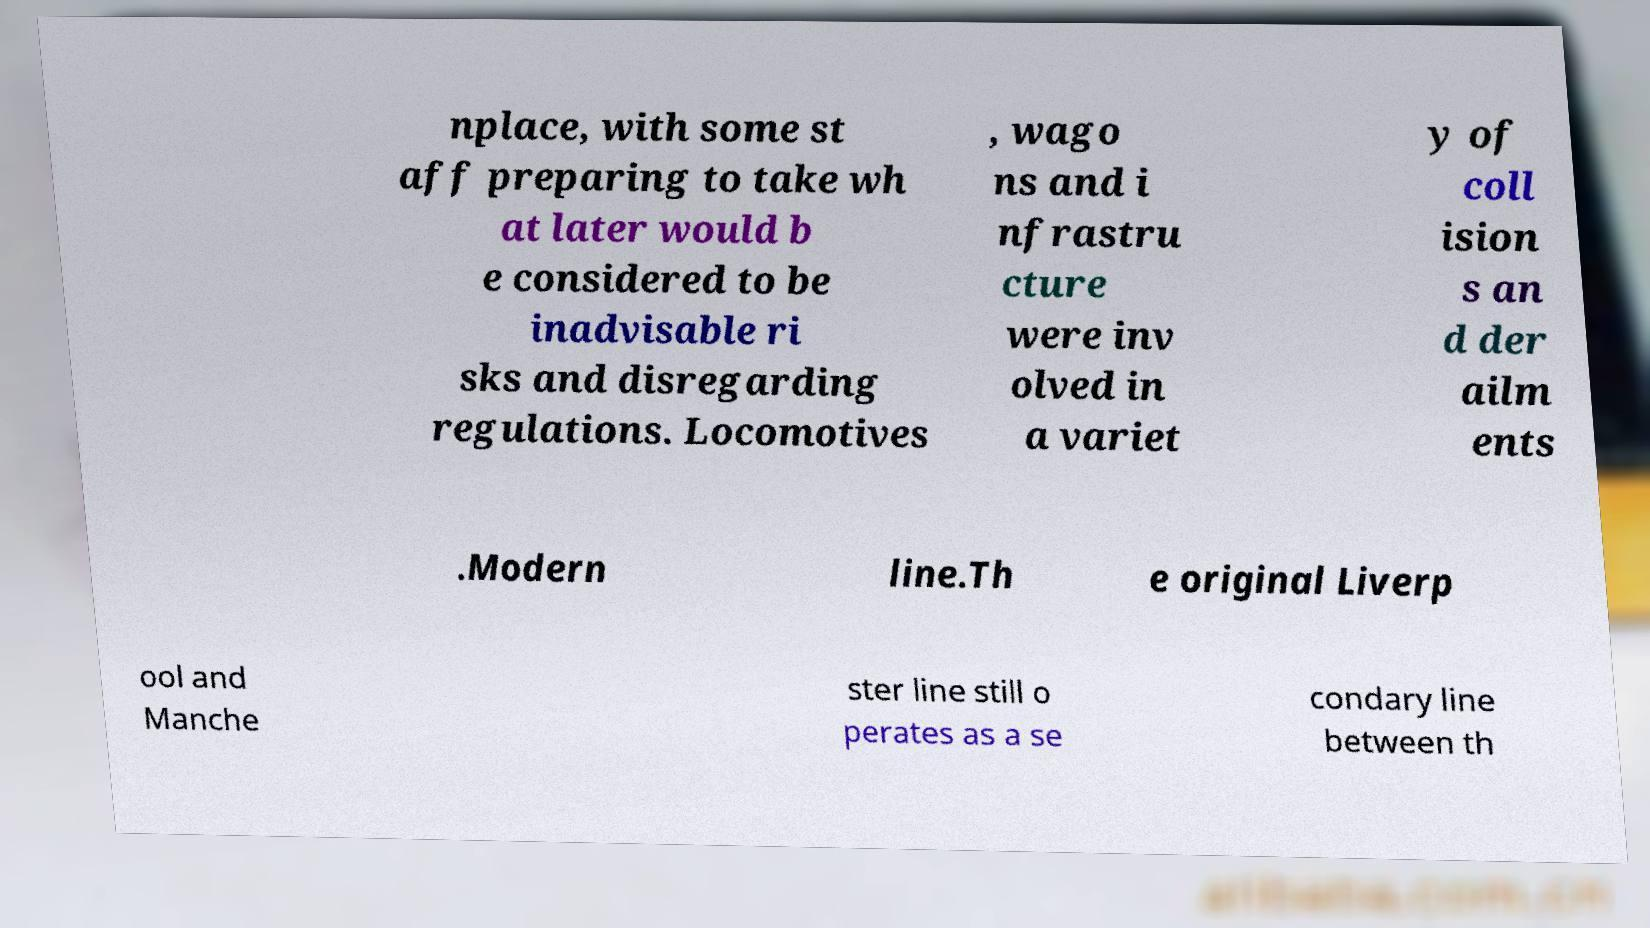Can you accurately transcribe the text from the provided image for me? nplace, with some st aff preparing to take wh at later would b e considered to be inadvisable ri sks and disregarding regulations. Locomotives , wago ns and i nfrastru cture were inv olved in a variet y of coll ision s an d der ailm ents .Modern line.Th e original Liverp ool and Manche ster line still o perates as a se condary line between th 